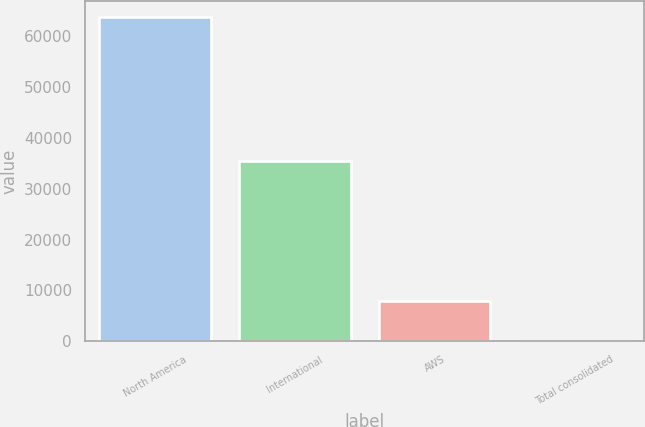Convert chart. <chart><loc_0><loc_0><loc_500><loc_500><bar_chart><fcel>North America<fcel>International<fcel>AWS<fcel>Total consolidated<nl><fcel>63708<fcel>35418<fcel>7880<fcel>20<nl></chart> 